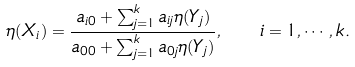Convert formula to latex. <formula><loc_0><loc_0><loc_500><loc_500>\eta ( X _ { i } ) = \frac { a _ { i 0 } + \sum _ { j = 1 } ^ { k } a _ { i j } \eta ( Y _ { j } ) } { a _ { 0 0 } + \sum _ { j = 1 } ^ { k } a _ { 0 j } \eta ( Y _ { j } ) } , \quad i = 1 , \cdots , k .</formula> 